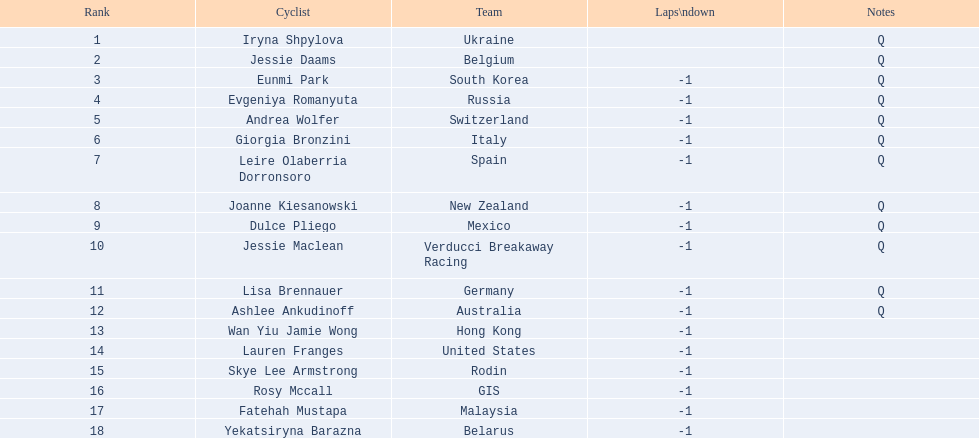Who are all of the cyclists in this race? Iryna Shpylova, Jessie Daams, Eunmi Park, Evgeniya Romanyuta, Andrea Wolfer, Giorgia Bronzini, Leire Olaberria Dorronsoro, Joanne Kiesanowski, Dulce Pliego, Jessie Maclean, Lisa Brennauer, Ashlee Ankudinoff, Wan Yiu Jamie Wong, Lauren Franges, Skye Lee Armstrong, Rosy Mccall, Fatehah Mustapa, Yekatsiryna Barazna. Of these, which one has the lowest numbered rank? Iryna Shpylova. 